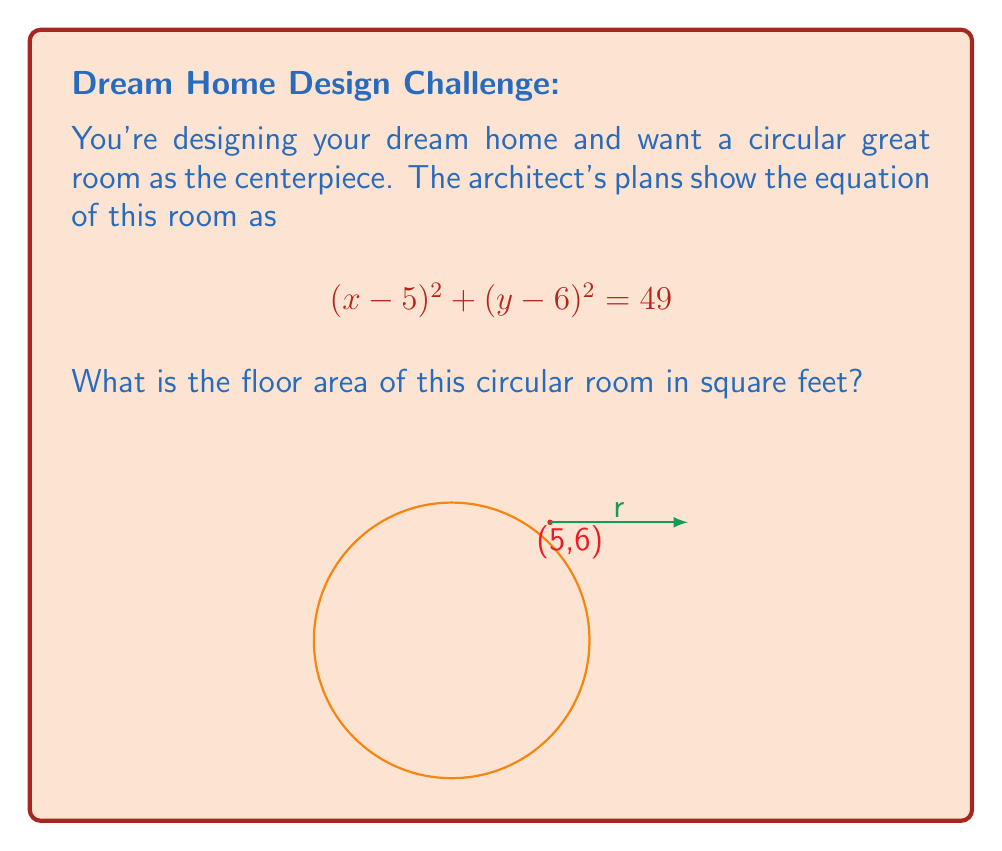Could you help me with this problem? Let's approach this step-by-step:

1) The general equation of a circle is $(x-h)^2 + (y-k)^2 = r^2$, where $(h,k)$ is the center and $r$ is the radius.

2) Comparing our equation $(x-5)^2 + (y-6)^2 = 49$ to the general form, we can see that:
   - The center is at (5,6)
   - $r^2 = 49$

3) To find the radius, we take the square root of both sides:
   $r = \sqrt{49} = 7$ feet

4) The area of a circle is given by the formula $A = \pi r^2$

5) Substituting our radius:
   $A = \pi (7)^2 = 49\pi$ square feet

6) If we want to give a decimal approximation:
   $A \approx 153.94$ square feet (rounded to two decimal places)
Answer: $49\pi$ sq ft or approximately 153.94 sq ft 